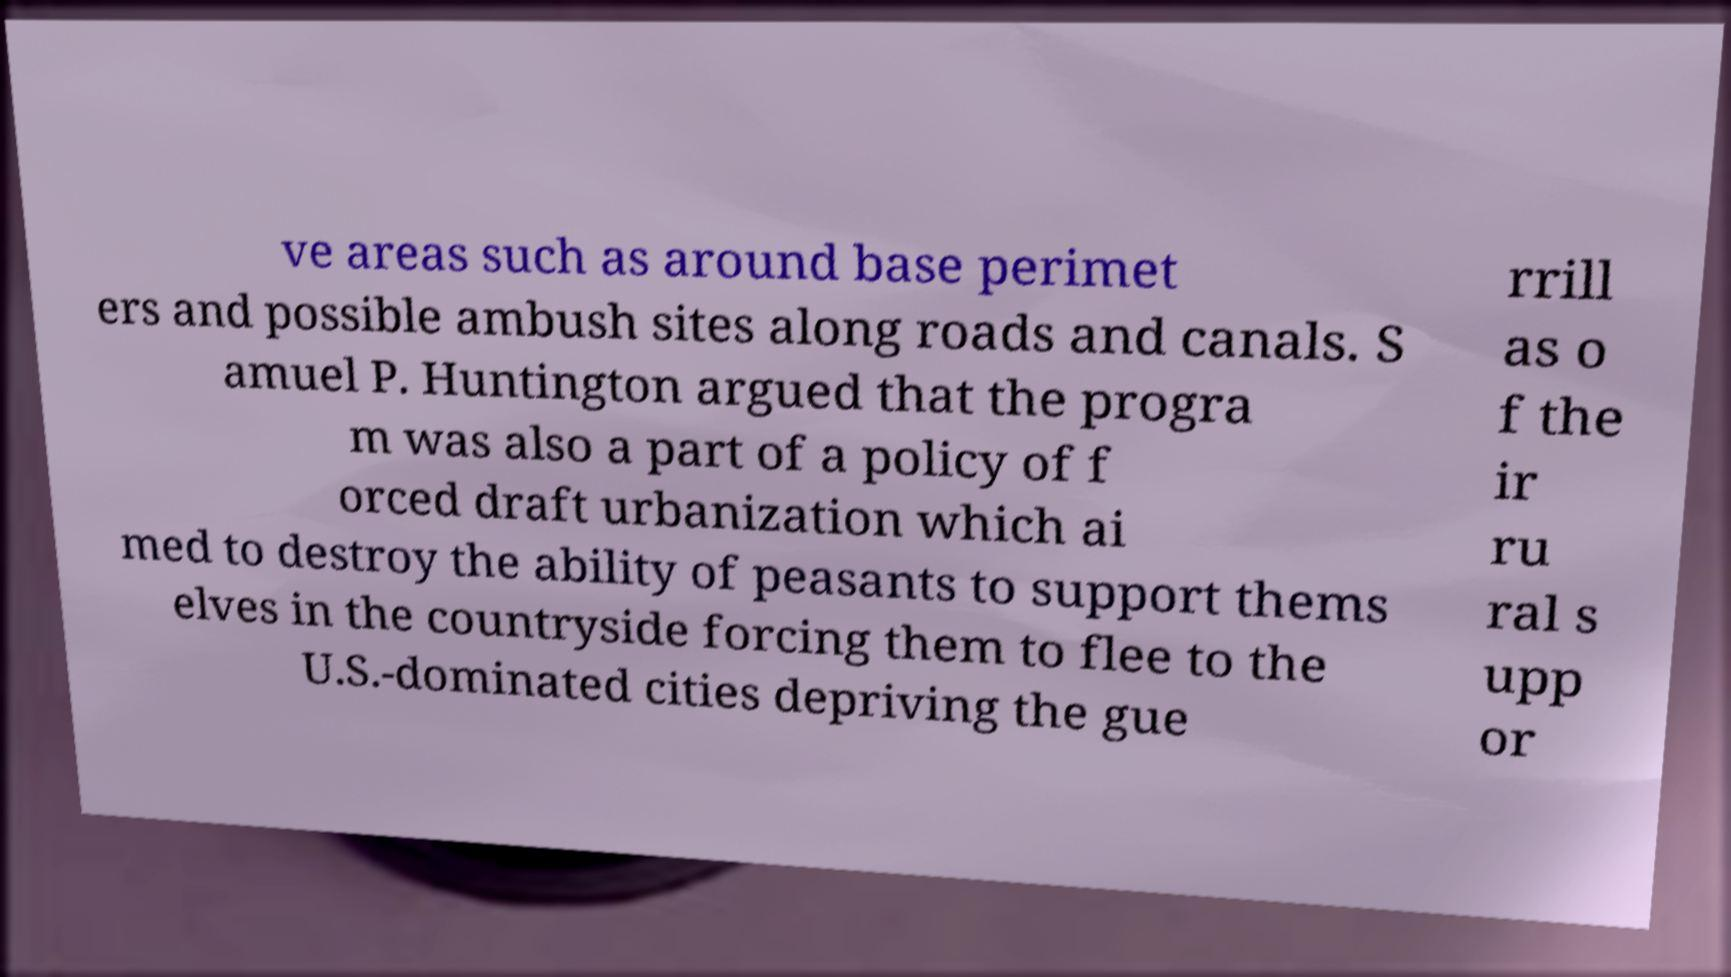For documentation purposes, I need the text within this image transcribed. Could you provide that? ve areas such as around base perimet ers and possible ambush sites along roads and canals. S amuel P. Huntington argued that the progra m was also a part of a policy of f orced draft urbanization which ai med to destroy the ability of peasants to support thems elves in the countryside forcing them to flee to the U.S.-dominated cities depriving the gue rrill as o f the ir ru ral s upp or 